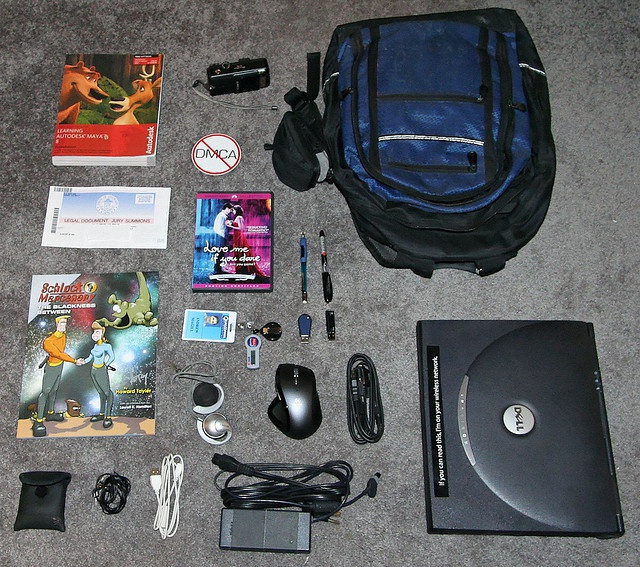Describe the objects in this image and their specific colors. I can see backpack in gray, black, and navy tones, laptop in gray and black tones, book in gray, lightgray, and darkgray tones, book in gray, red, black, darkgreen, and maroon tones, and mouse in gray, black, lightgray, and darkgray tones in this image. 